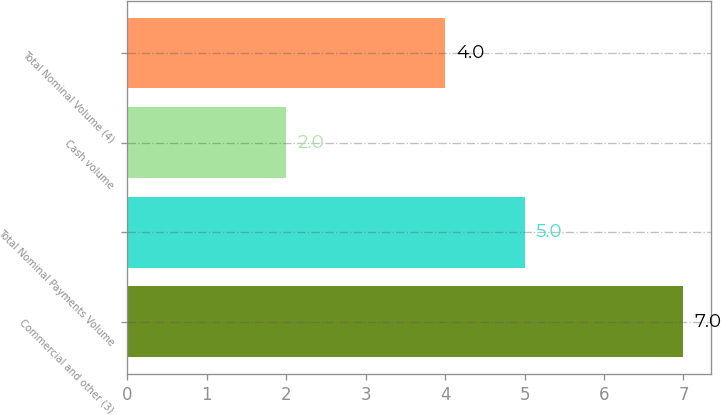<chart> <loc_0><loc_0><loc_500><loc_500><bar_chart><fcel>Commercial and other (3)<fcel>Total Nominal Payments Volume<fcel>Cash volume<fcel>Total Nominal Volume (4)<nl><fcel>7<fcel>5<fcel>2<fcel>4<nl></chart> 